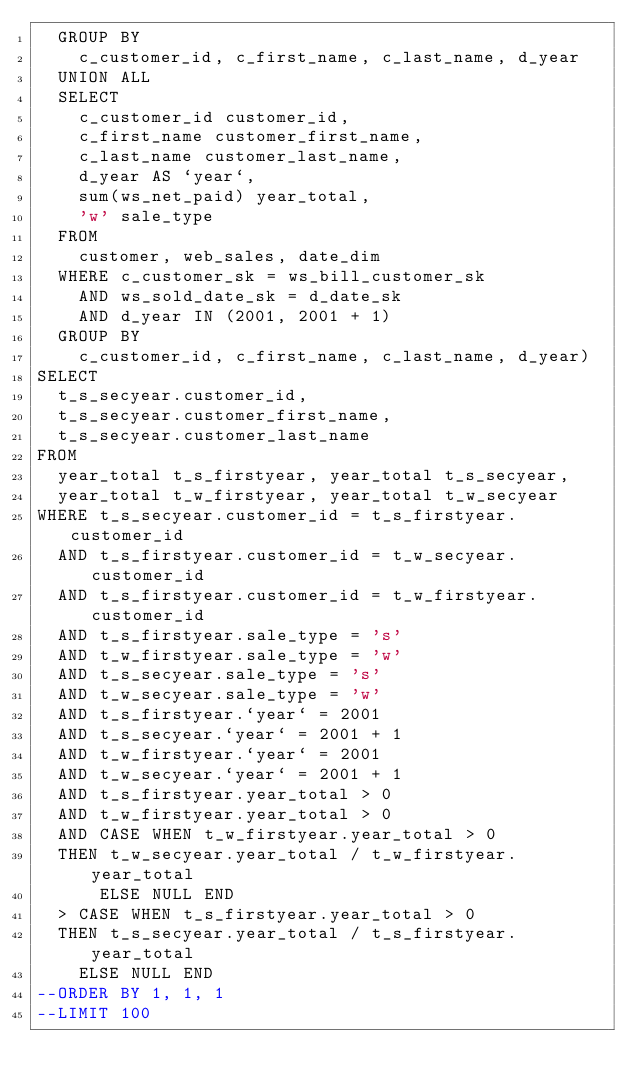Convert code to text. <code><loc_0><loc_0><loc_500><loc_500><_SQL_>  GROUP BY
    c_customer_id, c_first_name, c_last_name, d_year
  UNION ALL
  SELECT
    c_customer_id customer_id,
    c_first_name customer_first_name,
    c_last_name customer_last_name,
    d_year AS `year`,
    sum(ws_net_paid) year_total,
    'w' sale_type
  FROM
    customer, web_sales, date_dim
  WHERE c_customer_sk = ws_bill_customer_sk
    AND ws_sold_date_sk = d_date_sk
    AND d_year IN (2001, 2001 + 1)
  GROUP BY
    c_customer_id, c_first_name, c_last_name, d_year)
SELECT
  t_s_secyear.customer_id,
  t_s_secyear.customer_first_name,
  t_s_secyear.customer_last_name
FROM
  year_total t_s_firstyear, year_total t_s_secyear,
  year_total t_w_firstyear, year_total t_w_secyear
WHERE t_s_secyear.customer_id = t_s_firstyear.customer_id
  AND t_s_firstyear.customer_id = t_w_secyear.customer_id
  AND t_s_firstyear.customer_id = t_w_firstyear.customer_id
  AND t_s_firstyear.sale_type = 's'
  AND t_w_firstyear.sale_type = 'w'
  AND t_s_secyear.sale_type = 's'
  AND t_w_secyear.sale_type = 'w'
  AND t_s_firstyear.`year` = 2001
  AND t_s_secyear.`year` = 2001 + 1
  AND t_w_firstyear.`year` = 2001
  AND t_w_secyear.`year` = 2001 + 1
  AND t_s_firstyear.year_total > 0
  AND t_w_firstyear.year_total > 0
  AND CASE WHEN t_w_firstyear.year_total > 0
  THEN t_w_secyear.year_total / t_w_firstyear.year_total
      ELSE NULL END
  > CASE WHEN t_s_firstyear.year_total > 0
  THEN t_s_secyear.year_total / t_s_firstyear.year_total
    ELSE NULL END
--ORDER BY 1, 1, 1
--LIMIT 100
</code> 